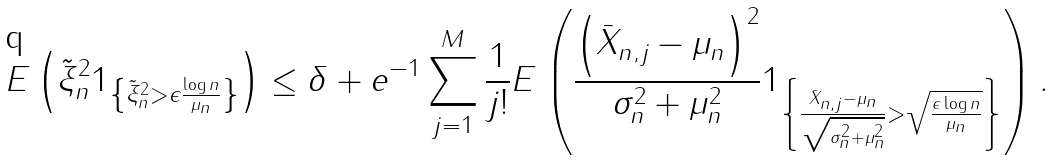<formula> <loc_0><loc_0><loc_500><loc_500>E \left ( \tilde { \xi } _ { n } ^ { 2 } 1 _ { \left \{ \tilde { \xi } _ { n } ^ { 2 } > \epsilon \frac { \log n } { \mu _ { n } } \right \} } \right ) \leq \delta + e ^ { - 1 } \sum _ { j = 1 } ^ { M } \frac { 1 } { j ! } E \left ( \frac { \left ( \bar { X } _ { n , j } - \mu _ { n } \right ) ^ { 2 } } { \sigma _ { n } ^ { 2 } + \mu _ { n } ^ { 2 } } 1 _ { \left \{ \frac { \bar { X } _ { n , j } - \mu _ { n } } { \sqrt { \sigma _ { n } ^ { 2 } + \mu _ { n } ^ { 2 } } } > \sqrt { \frac { \epsilon \log n } { \mu _ { n } } } \right \} } \right ) .</formula> 